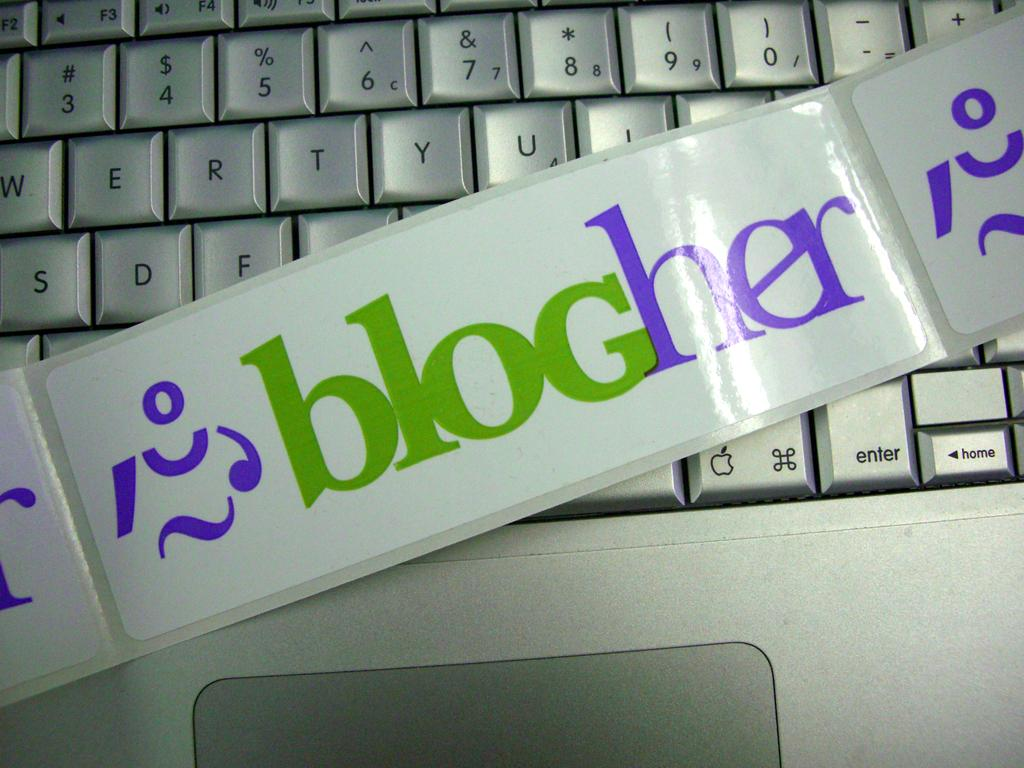<image>
Relay a brief, clear account of the picture shown. A sheet of stickers saying blogher is laying across a keyboard. 